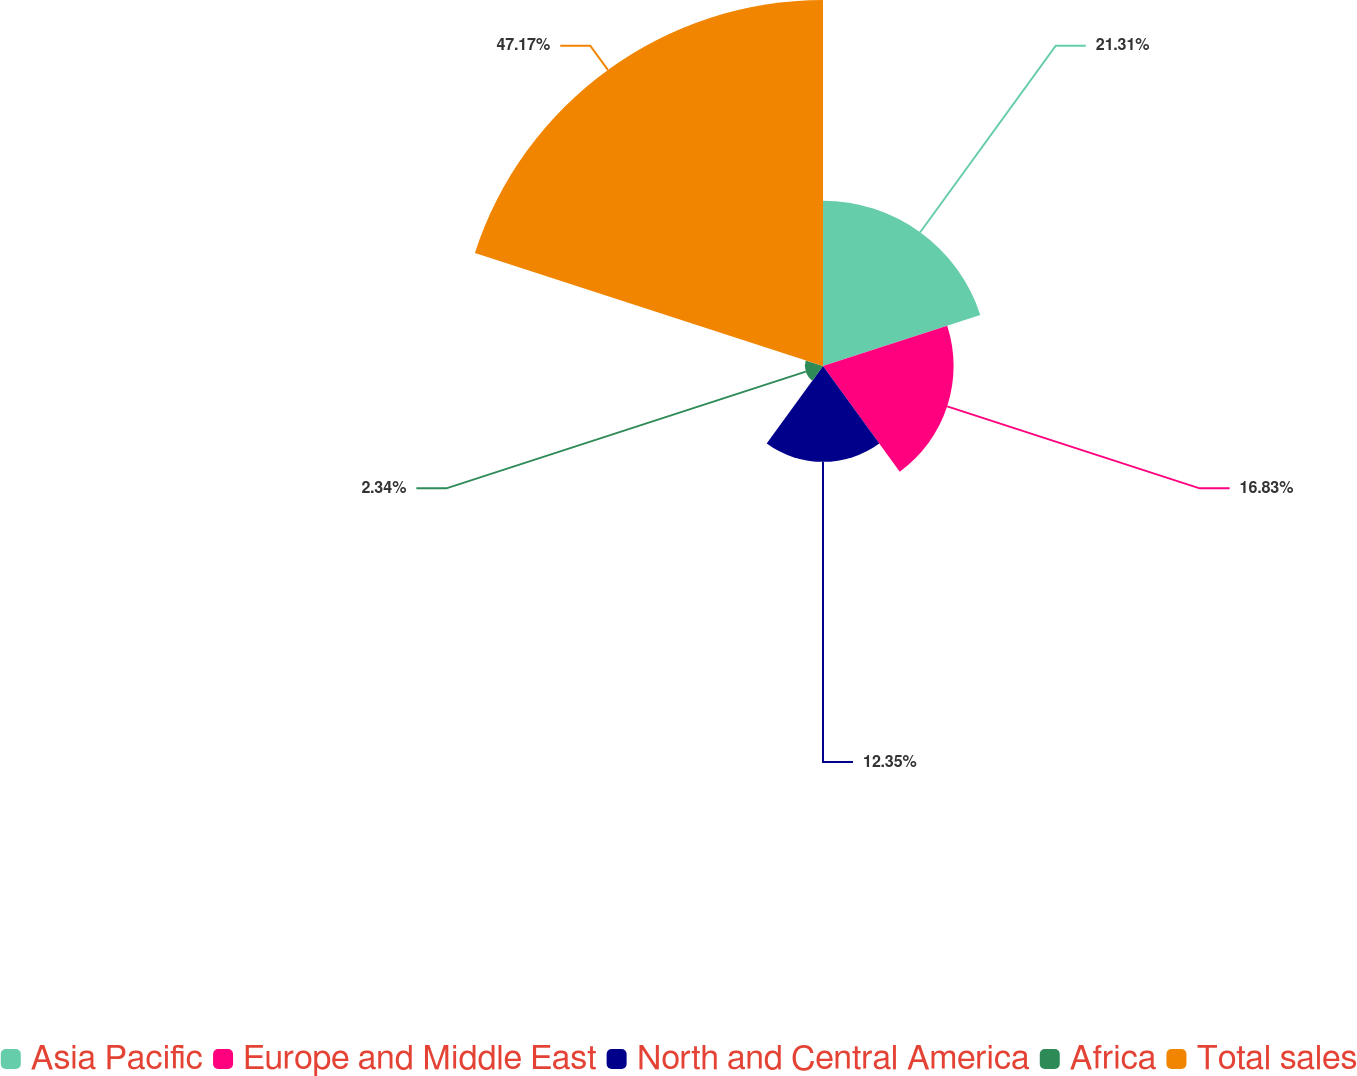<chart> <loc_0><loc_0><loc_500><loc_500><pie_chart><fcel>Asia Pacific<fcel>Europe and Middle East<fcel>North and Central America<fcel>Africa<fcel>Total sales<nl><fcel>21.31%<fcel>16.83%<fcel>12.35%<fcel>2.34%<fcel>47.17%<nl></chart> 